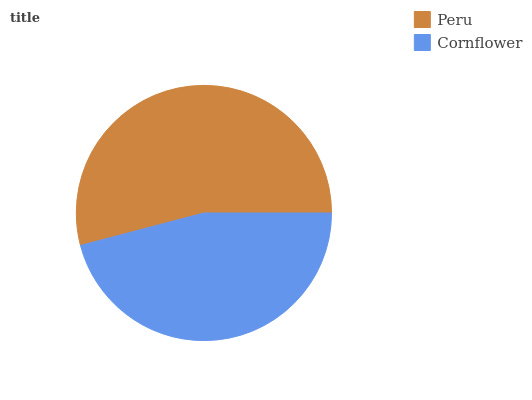Is Cornflower the minimum?
Answer yes or no. Yes. Is Peru the maximum?
Answer yes or no. Yes. Is Cornflower the maximum?
Answer yes or no. No. Is Peru greater than Cornflower?
Answer yes or no. Yes. Is Cornflower less than Peru?
Answer yes or no. Yes. Is Cornflower greater than Peru?
Answer yes or no. No. Is Peru less than Cornflower?
Answer yes or no. No. Is Peru the high median?
Answer yes or no. Yes. Is Cornflower the low median?
Answer yes or no. Yes. Is Cornflower the high median?
Answer yes or no. No. Is Peru the low median?
Answer yes or no. No. 